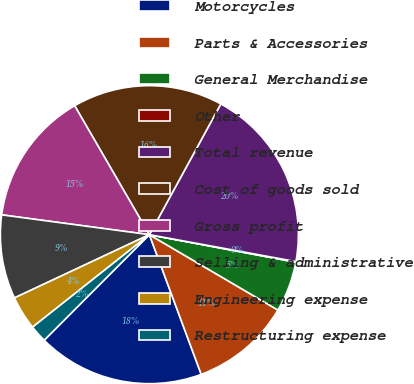Convert chart to OTSL. <chart><loc_0><loc_0><loc_500><loc_500><pie_chart><fcel>Motorcycles<fcel>Parts & Accessories<fcel>General Merchandise<fcel>Other<fcel>Total revenue<fcel>Cost of goods sold<fcel>Gross profit<fcel>Selling & administrative<fcel>Engineering expense<fcel>Restructuring expense<nl><fcel>18.13%<fcel>10.9%<fcel>5.48%<fcel>0.07%<fcel>19.93%<fcel>16.32%<fcel>14.52%<fcel>9.1%<fcel>3.68%<fcel>1.87%<nl></chart> 